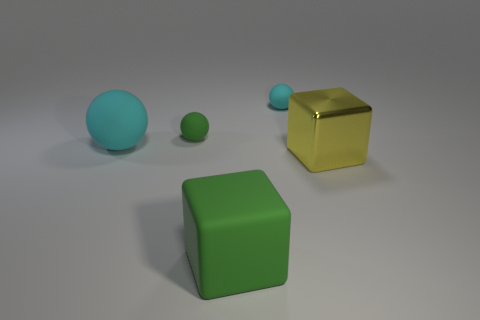Is there anything else that is the same size as the shiny object?
Offer a very short reply. Yes. Are there any other objects of the same shape as the small green rubber object?
Give a very brief answer. Yes. What is the color of the big matte object on the right side of the big rubber object that is left of the large matte cube?
Your response must be concise. Green. Are there more small green spheres than cyan spheres?
Give a very brief answer. No. What number of spheres have the same size as the yellow metallic cube?
Offer a very short reply. 1. Is the material of the big cyan thing the same as the large thing that is right of the green cube?
Ensure brevity in your answer.  No. Is the number of brown cylinders less than the number of big cyan matte things?
Your answer should be compact. Yes. Is there anything else of the same color as the large matte cube?
Make the answer very short. Yes. What is the shape of the other cyan thing that is made of the same material as the small cyan thing?
Offer a terse response. Sphere. How many small things are to the left of the big rubber object to the right of the cyan thing on the left side of the green rubber cube?
Keep it short and to the point. 1. 